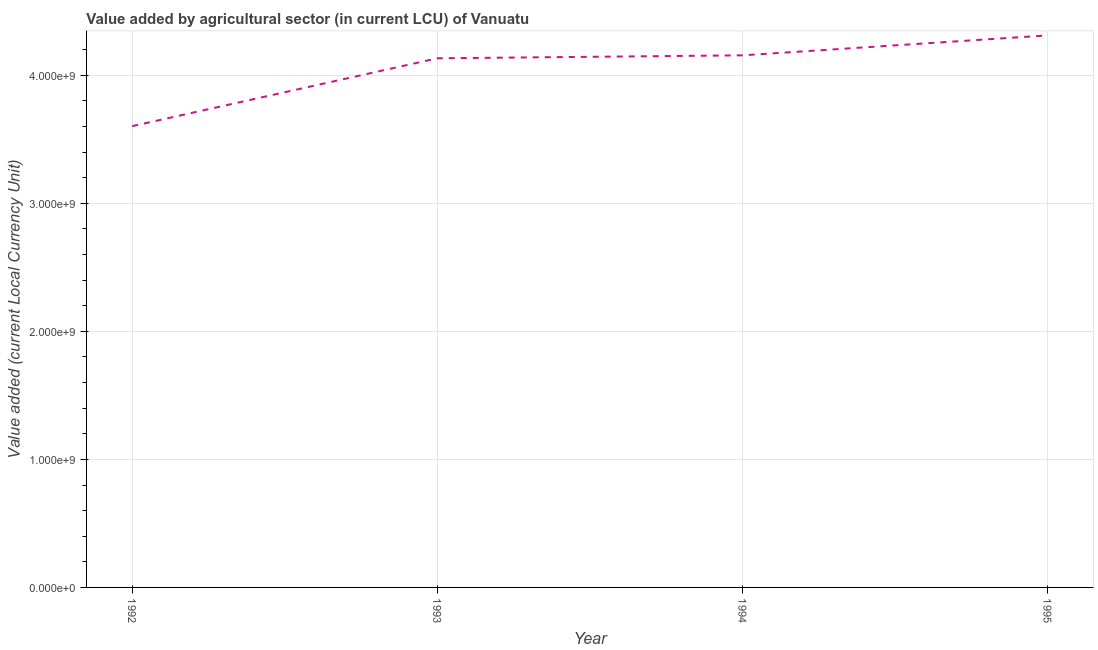What is the value added by agriculture sector in 1993?
Keep it short and to the point. 4.13e+09. Across all years, what is the maximum value added by agriculture sector?
Offer a terse response. 4.31e+09. Across all years, what is the minimum value added by agriculture sector?
Provide a short and direct response. 3.60e+09. In which year was the value added by agriculture sector maximum?
Give a very brief answer. 1995. What is the sum of the value added by agriculture sector?
Keep it short and to the point. 1.62e+1. What is the difference between the value added by agriculture sector in 1992 and 1994?
Your answer should be very brief. -5.53e+08. What is the average value added by agriculture sector per year?
Provide a succinct answer. 4.05e+09. What is the median value added by agriculture sector?
Give a very brief answer. 4.14e+09. What is the ratio of the value added by agriculture sector in 1993 to that in 1994?
Your response must be concise. 0.99. Is the value added by agriculture sector in 1994 less than that in 1995?
Your response must be concise. Yes. What is the difference between the highest and the second highest value added by agriculture sector?
Offer a very short reply. 1.56e+08. What is the difference between the highest and the lowest value added by agriculture sector?
Offer a very short reply. 7.09e+08. In how many years, is the value added by agriculture sector greater than the average value added by agriculture sector taken over all years?
Your response must be concise. 3. Does the value added by agriculture sector monotonically increase over the years?
Offer a terse response. Yes. How many lines are there?
Offer a terse response. 1. How many years are there in the graph?
Keep it short and to the point. 4. Are the values on the major ticks of Y-axis written in scientific E-notation?
Ensure brevity in your answer.  Yes. What is the title of the graph?
Your answer should be very brief. Value added by agricultural sector (in current LCU) of Vanuatu. What is the label or title of the Y-axis?
Offer a very short reply. Value added (current Local Currency Unit). What is the Value added (current Local Currency Unit) in 1992?
Ensure brevity in your answer.  3.60e+09. What is the Value added (current Local Currency Unit) of 1993?
Provide a short and direct response. 4.13e+09. What is the Value added (current Local Currency Unit) of 1994?
Offer a very short reply. 4.16e+09. What is the Value added (current Local Currency Unit) in 1995?
Make the answer very short. 4.31e+09. What is the difference between the Value added (current Local Currency Unit) in 1992 and 1993?
Your response must be concise. -5.30e+08. What is the difference between the Value added (current Local Currency Unit) in 1992 and 1994?
Your answer should be very brief. -5.53e+08. What is the difference between the Value added (current Local Currency Unit) in 1992 and 1995?
Your answer should be very brief. -7.09e+08. What is the difference between the Value added (current Local Currency Unit) in 1993 and 1994?
Keep it short and to the point. -2.30e+07. What is the difference between the Value added (current Local Currency Unit) in 1993 and 1995?
Provide a short and direct response. -1.79e+08. What is the difference between the Value added (current Local Currency Unit) in 1994 and 1995?
Your answer should be compact. -1.56e+08. What is the ratio of the Value added (current Local Currency Unit) in 1992 to that in 1993?
Give a very brief answer. 0.87. What is the ratio of the Value added (current Local Currency Unit) in 1992 to that in 1994?
Make the answer very short. 0.87. What is the ratio of the Value added (current Local Currency Unit) in 1992 to that in 1995?
Keep it short and to the point. 0.84. What is the ratio of the Value added (current Local Currency Unit) in 1993 to that in 1994?
Provide a succinct answer. 0.99. What is the ratio of the Value added (current Local Currency Unit) in 1993 to that in 1995?
Your answer should be compact. 0.96. 